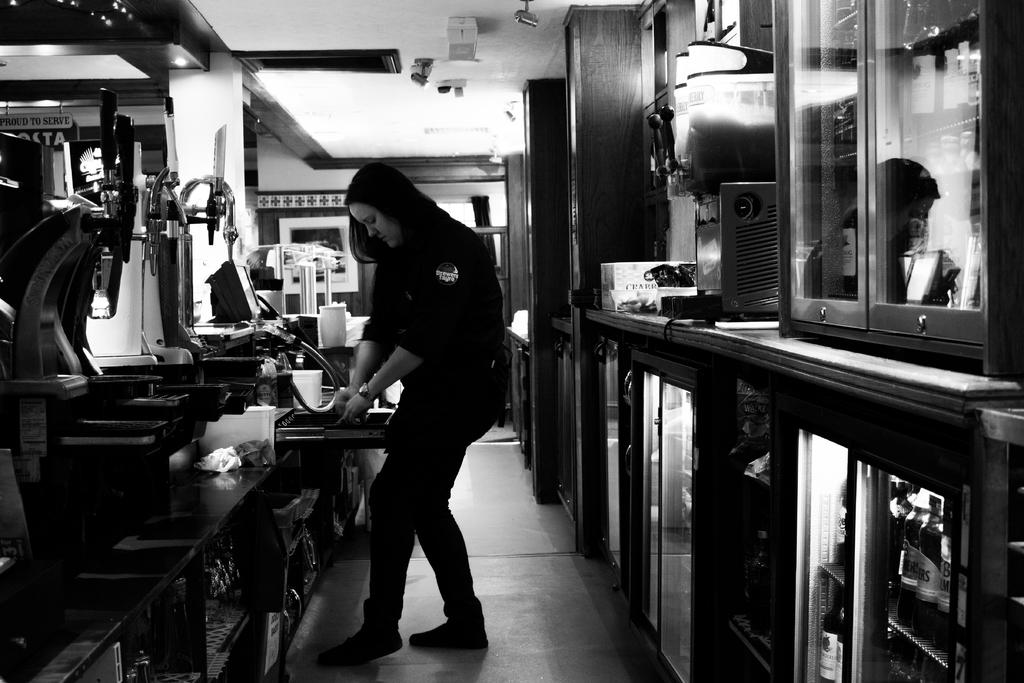What is the main subject in the middle of the image? There is a woman standing in the middle of the image. What can be seen on the left side of the image? There are machines on the left side of the image. What type of appliances are on the right side of the image? There are refrigerators on the right side of the image. What is the taste of the butter in the image? There is no butter present in the image, so it is not possible to determine its taste. 